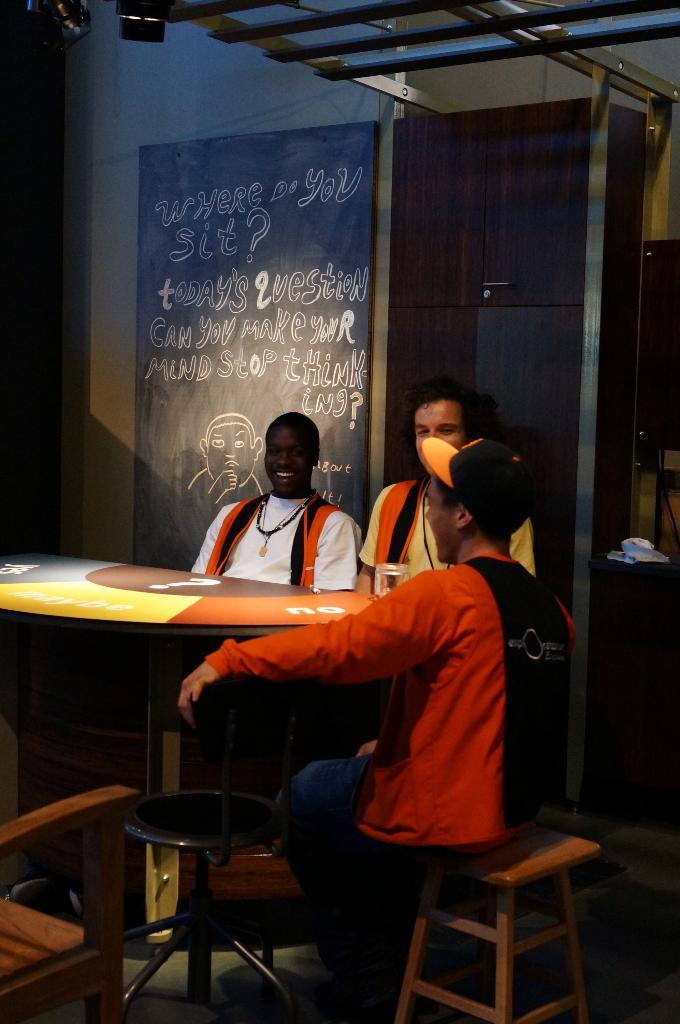How many people are in the image? There are three people in the image. What are the people doing in the image? The people are sitting in a chair and laughing. What is in front of the people? There is a table in front of the people. What type of quill is being used by the people in the image? There is no quill present in the image; the people are laughing and sitting in a chair. 